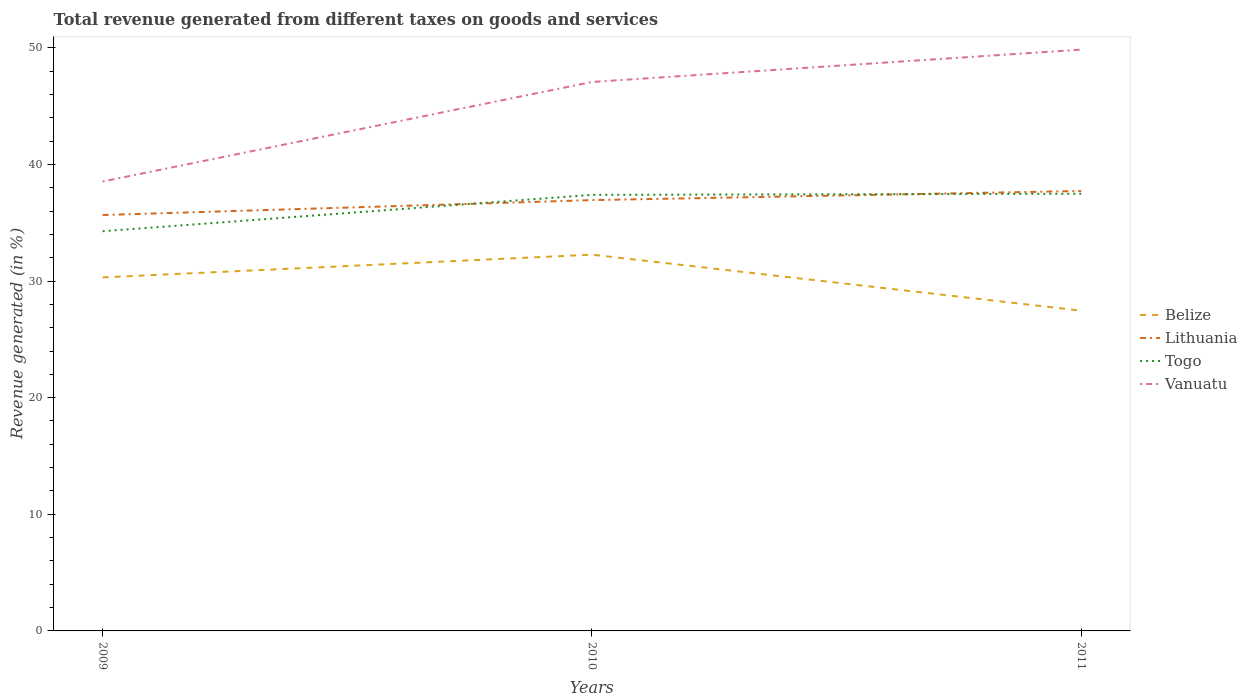How many different coloured lines are there?
Your answer should be compact. 4. Across all years, what is the maximum total revenue generated in Belize?
Provide a short and direct response. 27.46. In which year was the total revenue generated in Lithuania maximum?
Offer a very short reply. 2009. What is the total total revenue generated in Vanuatu in the graph?
Provide a succinct answer. -11.31. What is the difference between the highest and the second highest total revenue generated in Lithuania?
Ensure brevity in your answer.  2.06. What is the difference between the highest and the lowest total revenue generated in Togo?
Make the answer very short. 2. How many lines are there?
Ensure brevity in your answer.  4. How many years are there in the graph?
Keep it short and to the point. 3. What is the difference between two consecutive major ticks on the Y-axis?
Make the answer very short. 10. Are the values on the major ticks of Y-axis written in scientific E-notation?
Keep it short and to the point. No. Where does the legend appear in the graph?
Offer a very short reply. Center right. What is the title of the graph?
Your response must be concise. Total revenue generated from different taxes on goods and services. Does "Cyprus" appear as one of the legend labels in the graph?
Ensure brevity in your answer.  No. What is the label or title of the X-axis?
Give a very brief answer. Years. What is the label or title of the Y-axis?
Offer a terse response. Revenue generated (in %). What is the Revenue generated (in %) in Belize in 2009?
Provide a short and direct response. 30.31. What is the Revenue generated (in %) in Lithuania in 2009?
Offer a terse response. 35.66. What is the Revenue generated (in %) of Togo in 2009?
Offer a terse response. 34.27. What is the Revenue generated (in %) of Vanuatu in 2009?
Provide a short and direct response. 38.54. What is the Revenue generated (in %) of Belize in 2010?
Your response must be concise. 32.26. What is the Revenue generated (in %) of Lithuania in 2010?
Provide a succinct answer. 36.94. What is the Revenue generated (in %) of Togo in 2010?
Give a very brief answer. 37.39. What is the Revenue generated (in %) of Vanuatu in 2010?
Provide a short and direct response. 47.07. What is the Revenue generated (in %) in Belize in 2011?
Keep it short and to the point. 27.46. What is the Revenue generated (in %) in Lithuania in 2011?
Your response must be concise. 37.72. What is the Revenue generated (in %) of Togo in 2011?
Your response must be concise. 37.48. What is the Revenue generated (in %) of Vanuatu in 2011?
Your response must be concise. 49.84. Across all years, what is the maximum Revenue generated (in %) of Belize?
Your answer should be compact. 32.26. Across all years, what is the maximum Revenue generated (in %) in Lithuania?
Keep it short and to the point. 37.72. Across all years, what is the maximum Revenue generated (in %) in Togo?
Ensure brevity in your answer.  37.48. Across all years, what is the maximum Revenue generated (in %) of Vanuatu?
Provide a succinct answer. 49.84. Across all years, what is the minimum Revenue generated (in %) in Belize?
Keep it short and to the point. 27.46. Across all years, what is the minimum Revenue generated (in %) of Lithuania?
Your answer should be compact. 35.66. Across all years, what is the minimum Revenue generated (in %) in Togo?
Provide a short and direct response. 34.27. Across all years, what is the minimum Revenue generated (in %) of Vanuatu?
Give a very brief answer. 38.54. What is the total Revenue generated (in %) of Belize in the graph?
Offer a terse response. 90.04. What is the total Revenue generated (in %) of Lithuania in the graph?
Your answer should be compact. 110.32. What is the total Revenue generated (in %) of Togo in the graph?
Provide a short and direct response. 109.15. What is the total Revenue generated (in %) of Vanuatu in the graph?
Give a very brief answer. 135.45. What is the difference between the Revenue generated (in %) of Belize in 2009 and that in 2010?
Give a very brief answer. -1.95. What is the difference between the Revenue generated (in %) in Lithuania in 2009 and that in 2010?
Offer a very short reply. -1.28. What is the difference between the Revenue generated (in %) in Togo in 2009 and that in 2010?
Give a very brief answer. -3.12. What is the difference between the Revenue generated (in %) in Vanuatu in 2009 and that in 2010?
Your response must be concise. -8.53. What is the difference between the Revenue generated (in %) of Belize in 2009 and that in 2011?
Give a very brief answer. 2.85. What is the difference between the Revenue generated (in %) in Lithuania in 2009 and that in 2011?
Your answer should be very brief. -2.06. What is the difference between the Revenue generated (in %) in Togo in 2009 and that in 2011?
Give a very brief answer. -3.21. What is the difference between the Revenue generated (in %) in Vanuatu in 2009 and that in 2011?
Ensure brevity in your answer.  -11.31. What is the difference between the Revenue generated (in %) of Belize in 2010 and that in 2011?
Provide a succinct answer. 4.8. What is the difference between the Revenue generated (in %) of Lithuania in 2010 and that in 2011?
Ensure brevity in your answer.  -0.78. What is the difference between the Revenue generated (in %) of Togo in 2010 and that in 2011?
Provide a succinct answer. -0.09. What is the difference between the Revenue generated (in %) of Vanuatu in 2010 and that in 2011?
Offer a very short reply. -2.77. What is the difference between the Revenue generated (in %) of Belize in 2009 and the Revenue generated (in %) of Lithuania in 2010?
Your answer should be compact. -6.63. What is the difference between the Revenue generated (in %) of Belize in 2009 and the Revenue generated (in %) of Togo in 2010?
Your answer should be very brief. -7.08. What is the difference between the Revenue generated (in %) in Belize in 2009 and the Revenue generated (in %) in Vanuatu in 2010?
Offer a very short reply. -16.76. What is the difference between the Revenue generated (in %) of Lithuania in 2009 and the Revenue generated (in %) of Togo in 2010?
Keep it short and to the point. -1.73. What is the difference between the Revenue generated (in %) in Lithuania in 2009 and the Revenue generated (in %) in Vanuatu in 2010?
Offer a terse response. -11.41. What is the difference between the Revenue generated (in %) in Togo in 2009 and the Revenue generated (in %) in Vanuatu in 2010?
Ensure brevity in your answer.  -12.8. What is the difference between the Revenue generated (in %) in Belize in 2009 and the Revenue generated (in %) in Lithuania in 2011?
Offer a terse response. -7.41. What is the difference between the Revenue generated (in %) of Belize in 2009 and the Revenue generated (in %) of Togo in 2011?
Your answer should be very brief. -7.17. What is the difference between the Revenue generated (in %) in Belize in 2009 and the Revenue generated (in %) in Vanuatu in 2011?
Your response must be concise. -19.53. What is the difference between the Revenue generated (in %) in Lithuania in 2009 and the Revenue generated (in %) in Togo in 2011?
Your answer should be compact. -1.82. What is the difference between the Revenue generated (in %) of Lithuania in 2009 and the Revenue generated (in %) of Vanuatu in 2011?
Ensure brevity in your answer.  -14.18. What is the difference between the Revenue generated (in %) in Togo in 2009 and the Revenue generated (in %) in Vanuatu in 2011?
Your response must be concise. -15.57. What is the difference between the Revenue generated (in %) in Belize in 2010 and the Revenue generated (in %) in Lithuania in 2011?
Keep it short and to the point. -5.46. What is the difference between the Revenue generated (in %) in Belize in 2010 and the Revenue generated (in %) in Togo in 2011?
Your answer should be very brief. -5.22. What is the difference between the Revenue generated (in %) of Belize in 2010 and the Revenue generated (in %) of Vanuatu in 2011?
Your answer should be compact. -17.58. What is the difference between the Revenue generated (in %) of Lithuania in 2010 and the Revenue generated (in %) of Togo in 2011?
Your answer should be compact. -0.55. What is the difference between the Revenue generated (in %) in Lithuania in 2010 and the Revenue generated (in %) in Vanuatu in 2011?
Offer a terse response. -12.9. What is the difference between the Revenue generated (in %) of Togo in 2010 and the Revenue generated (in %) of Vanuatu in 2011?
Offer a terse response. -12.45. What is the average Revenue generated (in %) in Belize per year?
Keep it short and to the point. 30.01. What is the average Revenue generated (in %) of Lithuania per year?
Make the answer very short. 36.77. What is the average Revenue generated (in %) in Togo per year?
Your response must be concise. 36.38. What is the average Revenue generated (in %) of Vanuatu per year?
Provide a succinct answer. 45.15. In the year 2009, what is the difference between the Revenue generated (in %) in Belize and Revenue generated (in %) in Lithuania?
Your answer should be very brief. -5.35. In the year 2009, what is the difference between the Revenue generated (in %) of Belize and Revenue generated (in %) of Togo?
Your answer should be very brief. -3.96. In the year 2009, what is the difference between the Revenue generated (in %) of Belize and Revenue generated (in %) of Vanuatu?
Keep it short and to the point. -8.22. In the year 2009, what is the difference between the Revenue generated (in %) of Lithuania and Revenue generated (in %) of Togo?
Provide a succinct answer. 1.39. In the year 2009, what is the difference between the Revenue generated (in %) in Lithuania and Revenue generated (in %) in Vanuatu?
Provide a short and direct response. -2.87. In the year 2009, what is the difference between the Revenue generated (in %) in Togo and Revenue generated (in %) in Vanuatu?
Make the answer very short. -4.26. In the year 2010, what is the difference between the Revenue generated (in %) in Belize and Revenue generated (in %) in Lithuania?
Offer a very short reply. -4.68. In the year 2010, what is the difference between the Revenue generated (in %) of Belize and Revenue generated (in %) of Togo?
Make the answer very short. -5.13. In the year 2010, what is the difference between the Revenue generated (in %) of Belize and Revenue generated (in %) of Vanuatu?
Provide a short and direct response. -14.8. In the year 2010, what is the difference between the Revenue generated (in %) in Lithuania and Revenue generated (in %) in Togo?
Provide a short and direct response. -0.45. In the year 2010, what is the difference between the Revenue generated (in %) of Lithuania and Revenue generated (in %) of Vanuatu?
Offer a terse response. -10.13. In the year 2010, what is the difference between the Revenue generated (in %) of Togo and Revenue generated (in %) of Vanuatu?
Offer a terse response. -9.68. In the year 2011, what is the difference between the Revenue generated (in %) in Belize and Revenue generated (in %) in Lithuania?
Your answer should be very brief. -10.26. In the year 2011, what is the difference between the Revenue generated (in %) in Belize and Revenue generated (in %) in Togo?
Give a very brief answer. -10.02. In the year 2011, what is the difference between the Revenue generated (in %) in Belize and Revenue generated (in %) in Vanuatu?
Provide a short and direct response. -22.38. In the year 2011, what is the difference between the Revenue generated (in %) in Lithuania and Revenue generated (in %) in Togo?
Give a very brief answer. 0.24. In the year 2011, what is the difference between the Revenue generated (in %) of Lithuania and Revenue generated (in %) of Vanuatu?
Your response must be concise. -12.12. In the year 2011, what is the difference between the Revenue generated (in %) of Togo and Revenue generated (in %) of Vanuatu?
Your answer should be very brief. -12.36. What is the ratio of the Revenue generated (in %) in Belize in 2009 to that in 2010?
Provide a short and direct response. 0.94. What is the ratio of the Revenue generated (in %) in Lithuania in 2009 to that in 2010?
Offer a very short reply. 0.97. What is the ratio of the Revenue generated (in %) in Togo in 2009 to that in 2010?
Offer a very short reply. 0.92. What is the ratio of the Revenue generated (in %) of Vanuatu in 2009 to that in 2010?
Offer a very short reply. 0.82. What is the ratio of the Revenue generated (in %) of Belize in 2009 to that in 2011?
Your response must be concise. 1.1. What is the ratio of the Revenue generated (in %) in Lithuania in 2009 to that in 2011?
Provide a succinct answer. 0.95. What is the ratio of the Revenue generated (in %) in Togo in 2009 to that in 2011?
Keep it short and to the point. 0.91. What is the ratio of the Revenue generated (in %) in Vanuatu in 2009 to that in 2011?
Your response must be concise. 0.77. What is the ratio of the Revenue generated (in %) in Belize in 2010 to that in 2011?
Ensure brevity in your answer.  1.17. What is the ratio of the Revenue generated (in %) of Lithuania in 2010 to that in 2011?
Offer a very short reply. 0.98. What is the ratio of the Revenue generated (in %) in Togo in 2010 to that in 2011?
Ensure brevity in your answer.  1. What is the ratio of the Revenue generated (in %) in Vanuatu in 2010 to that in 2011?
Provide a succinct answer. 0.94. What is the difference between the highest and the second highest Revenue generated (in %) in Belize?
Your response must be concise. 1.95. What is the difference between the highest and the second highest Revenue generated (in %) of Lithuania?
Provide a succinct answer. 0.78. What is the difference between the highest and the second highest Revenue generated (in %) in Togo?
Provide a short and direct response. 0.09. What is the difference between the highest and the second highest Revenue generated (in %) of Vanuatu?
Ensure brevity in your answer.  2.77. What is the difference between the highest and the lowest Revenue generated (in %) in Belize?
Provide a succinct answer. 4.8. What is the difference between the highest and the lowest Revenue generated (in %) in Lithuania?
Give a very brief answer. 2.06. What is the difference between the highest and the lowest Revenue generated (in %) in Togo?
Offer a terse response. 3.21. What is the difference between the highest and the lowest Revenue generated (in %) of Vanuatu?
Offer a terse response. 11.31. 